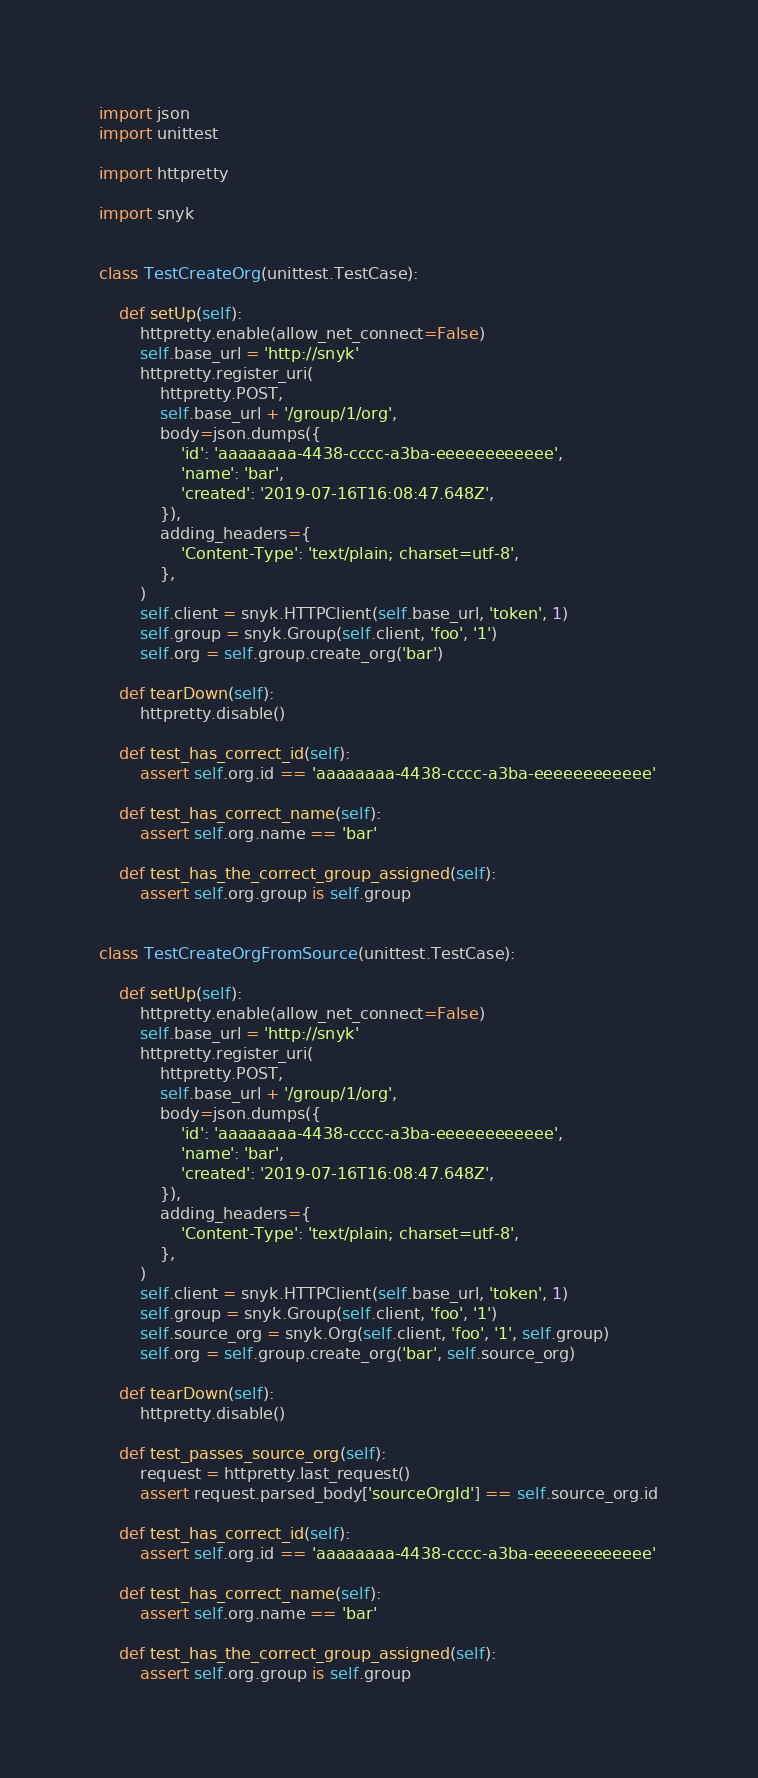Convert code to text. <code><loc_0><loc_0><loc_500><loc_500><_Python_>import json
import unittest

import httpretty

import snyk


class TestCreateOrg(unittest.TestCase):

    def setUp(self):
        httpretty.enable(allow_net_connect=False)
        self.base_url = 'http://snyk'
        httpretty.register_uri(
            httpretty.POST,
            self.base_url + '/group/1/org',
            body=json.dumps({
                'id': 'aaaaaaaa-4438-cccc-a3ba-eeeeeeeeeeee',
                'name': 'bar',
                'created': '2019-07-16T16:08:47.648Z',
            }),
            adding_headers={
                'Content-Type': 'text/plain; charset=utf-8',
            },
        )
        self.client = snyk.HTTPClient(self.base_url, 'token', 1)
        self.group = snyk.Group(self.client, 'foo', '1')
        self.org = self.group.create_org('bar')

    def tearDown(self):
        httpretty.disable()

    def test_has_correct_id(self):
        assert self.org.id == 'aaaaaaaa-4438-cccc-a3ba-eeeeeeeeeeee'

    def test_has_correct_name(self):
        assert self.org.name == 'bar'

    def test_has_the_correct_group_assigned(self):
        assert self.org.group is self.group


class TestCreateOrgFromSource(unittest.TestCase):

    def setUp(self):
        httpretty.enable(allow_net_connect=False)
        self.base_url = 'http://snyk'
        httpretty.register_uri(
            httpretty.POST,
            self.base_url + '/group/1/org',
            body=json.dumps({
                'id': 'aaaaaaaa-4438-cccc-a3ba-eeeeeeeeeeee',
                'name': 'bar',
                'created': '2019-07-16T16:08:47.648Z',
            }),
            adding_headers={
                'Content-Type': 'text/plain; charset=utf-8',
            },
        )
        self.client = snyk.HTTPClient(self.base_url, 'token', 1)
        self.group = snyk.Group(self.client, 'foo', '1')
        self.source_org = snyk.Org(self.client, 'foo', '1', self.group)
        self.org = self.group.create_org('bar', self.source_org)

    def tearDown(self):
        httpretty.disable()

    def test_passes_source_org(self):
        request = httpretty.last_request()
        assert request.parsed_body['sourceOrgId'] == self.source_org.id

    def test_has_correct_id(self):
        assert self.org.id == 'aaaaaaaa-4438-cccc-a3ba-eeeeeeeeeeee'

    def test_has_correct_name(self):
        assert self.org.name == 'bar'

    def test_has_the_correct_group_assigned(self):
        assert self.org.group is self.group
</code> 